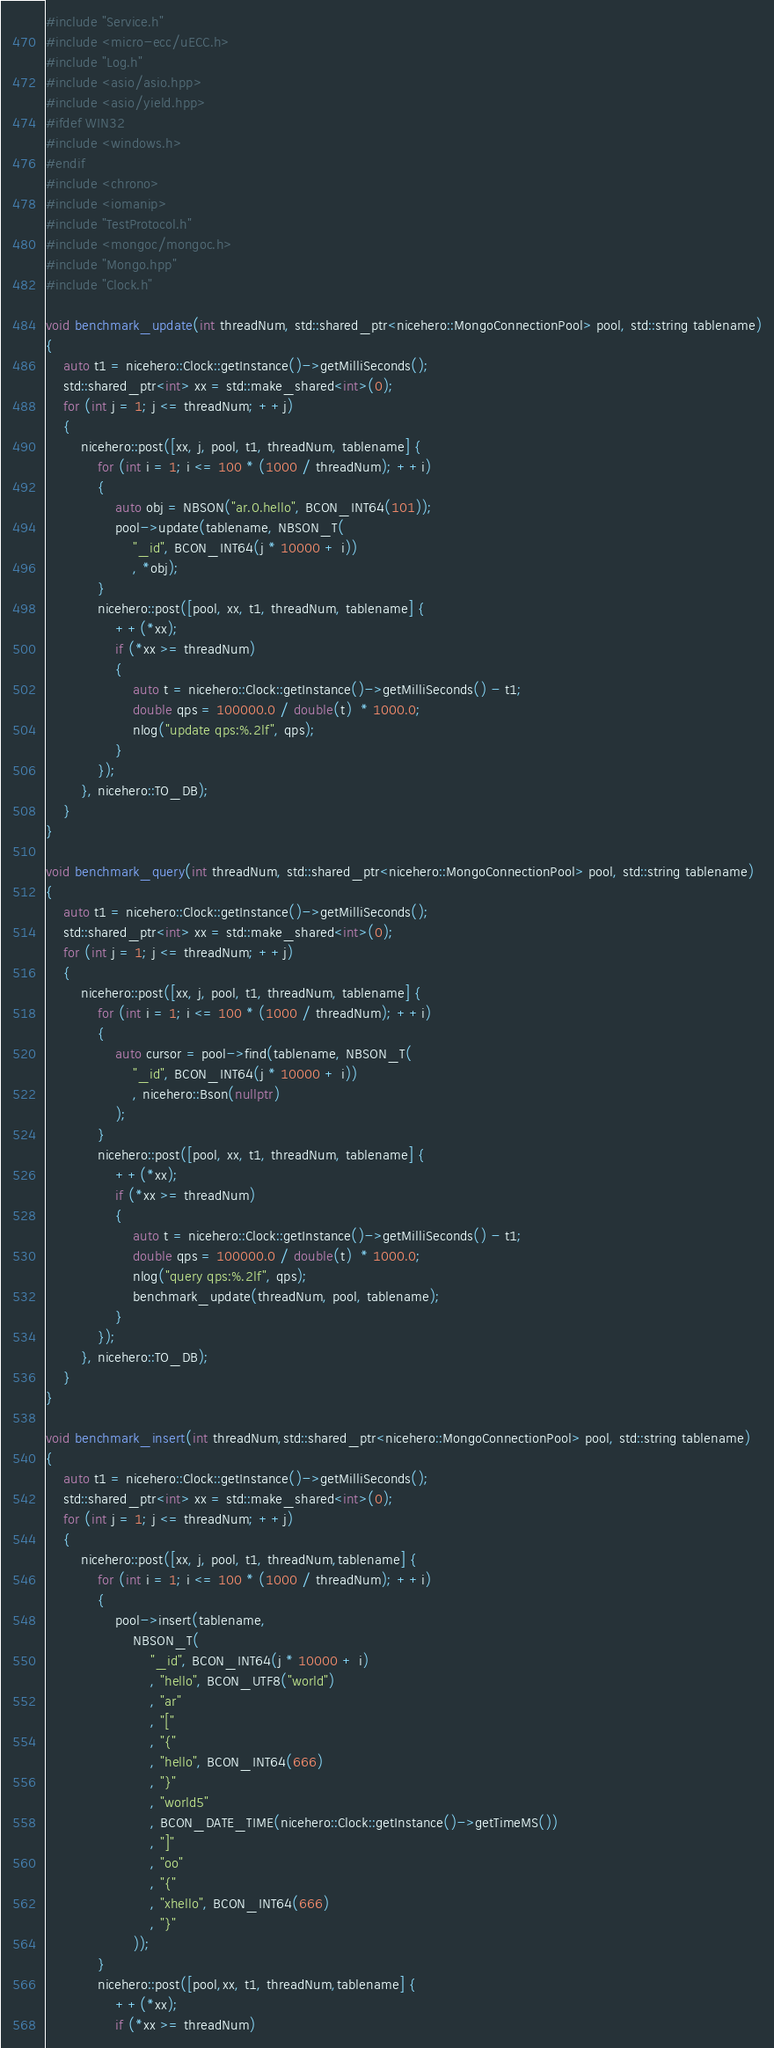<code> <loc_0><loc_0><loc_500><loc_500><_C++_>#include "Service.h"
#include <micro-ecc/uECC.h>
#include "Log.h"
#include <asio/asio.hpp>
#include <asio/yield.hpp>
#ifdef WIN32
#include <windows.h>
#endif
#include <chrono>
#include <iomanip>
#include "TestProtocol.h"
#include <mongoc/mongoc.h>
#include "Mongo.hpp"
#include "Clock.h"

void benchmark_update(int threadNum, std::shared_ptr<nicehero::MongoConnectionPool> pool, std::string tablename)
{
	auto t1 = nicehero::Clock::getInstance()->getMilliSeconds();
	std::shared_ptr<int> xx = std::make_shared<int>(0);
	for (int j = 1; j <= threadNum; ++j)
	{
		nicehero::post([xx, j, pool, t1, threadNum, tablename] {
			for (int i = 1; i <= 100 * (1000 / threadNum); ++i)
			{
				auto obj = NBSON("ar.0.hello", BCON_INT64(101));
				pool->update(tablename, NBSON_T(
					"_id", BCON_INT64(j * 10000 + i))
					, *obj);
			}
			nicehero::post([pool, xx, t1, threadNum, tablename] {
				++(*xx);
				if (*xx >= threadNum)
				{
					auto t = nicehero::Clock::getInstance()->getMilliSeconds() - t1;
					double qps = 100000.0 / double(t)  * 1000.0;
					nlog("update qps:%.2lf", qps);
				}
			});
		}, nicehero::TO_DB);
	}
}

void benchmark_query(int threadNum, std::shared_ptr<nicehero::MongoConnectionPool> pool, std::string tablename)
{
	auto t1 = nicehero::Clock::getInstance()->getMilliSeconds();
	std::shared_ptr<int> xx = std::make_shared<int>(0);
	for (int j = 1; j <= threadNum; ++j)
	{
		nicehero::post([xx, j, pool, t1, threadNum, tablename] {
			for (int i = 1; i <= 100 * (1000 / threadNum); ++i)
			{
				auto cursor = pool->find(tablename, NBSON_T(
					"_id", BCON_INT64(j * 10000 + i))
					, nicehero::Bson(nullptr)
				);
			}
			nicehero::post([pool, xx, t1, threadNum, tablename] {
				++(*xx);
				if (*xx >= threadNum)
				{
					auto t = nicehero::Clock::getInstance()->getMilliSeconds() - t1;
					double qps = 100000.0 / double(t)  * 1000.0;
					nlog("query qps:%.2lf", qps);
					benchmark_update(threadNum, pool, tablename);
				}
			});
		}, nicehero::TO_DB);
	}
}

void benchmark_insert(int threadNum,std::shared_ptr<nicehero::MongoConnectionPool> pool, std::string tablename)
{
	auto t1 = nicehero::Clock::getInstance()->getMilliSeconds();
	std::shared_ptr<int> xx = std::make_shared<int>(0);
	for (int j = 1; j <= threadNum; ++j)
	{
		nicehero::post([xx, j, pool, t1, threadNum,tablename] {
			for (int i = 1; i <= 100 * (1000 / threadNum); ++i)
			{
				pool->insert(tablename,
					NBSON_T(
						"_id", BCON_INT64(j * 10000 + i)
						, "hello", BCON_UTF8("world")
						, "ar"
						, "["
						, "{"
						, "hello", BCON_INT64(666)
						, "}"
						, "world5"
						, BCON_DATE_TIME(nicehero::Clock::getInstance()->getTimeMS())
						, "]"
						, "oo"
						, "{"
						, "xhello", BCON_INT64(666)
						, "}"
					));
			}
			nicehero::post([pool,xx, t1, threadNum,tablename] {
				++(*xx);
				if (*xx >= threadNum)</code> 